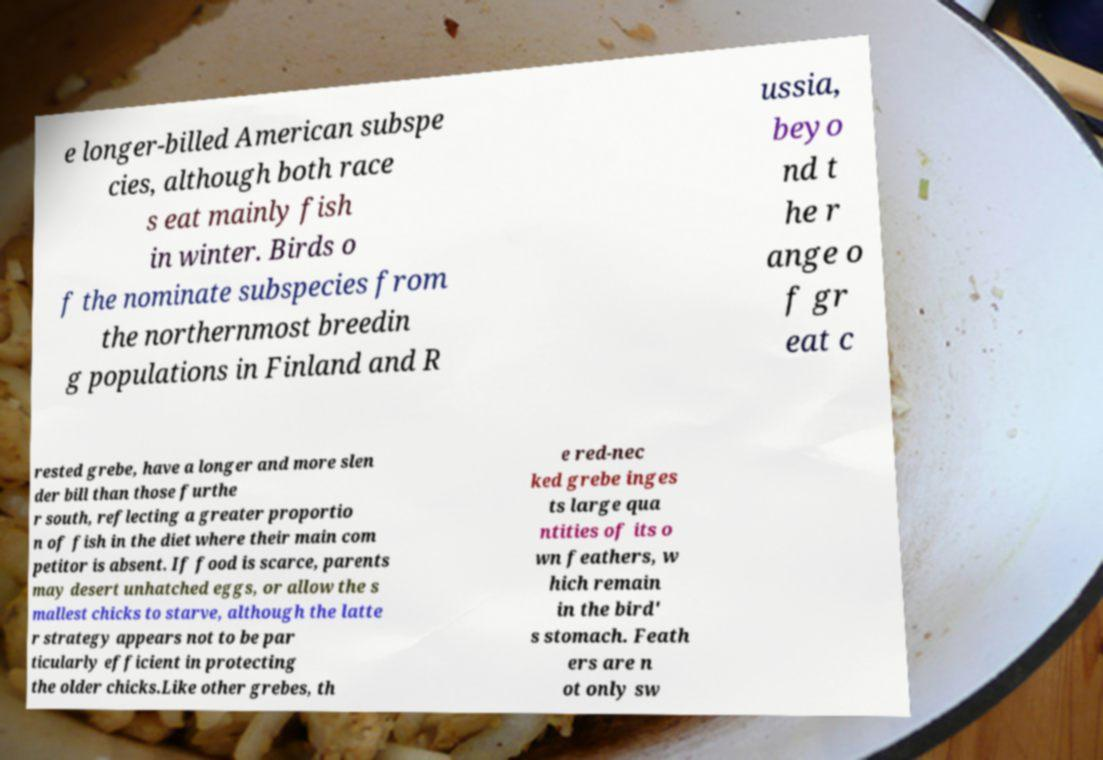I need the written content from this picture converted into text. Can you do that? e longer-billed American subspe cies, although both race s eat mainly fish in winter. Birds o f the nominate subspecies from the northernmost breedin g populations in Finland and R ussia, beyo nd t he r ange o f gr eat c rested grebe, have a longer and more slen der bill than those furthe r south, reflecting a greater proportio n of fish in the diet where their main com petitor is absent. If food is scarce, parents may desert unhatched eggs, or allow the s mallest chicks to starve, although the latte r strategy appears not to be par ticularly efficient in protecting the older chicks.Like other grebes, th e red-nec ked grebe inges ts large qua ntities of its o wn feathers, w hich remain in the bird' s stomach. Feath ers are n ot only sw 